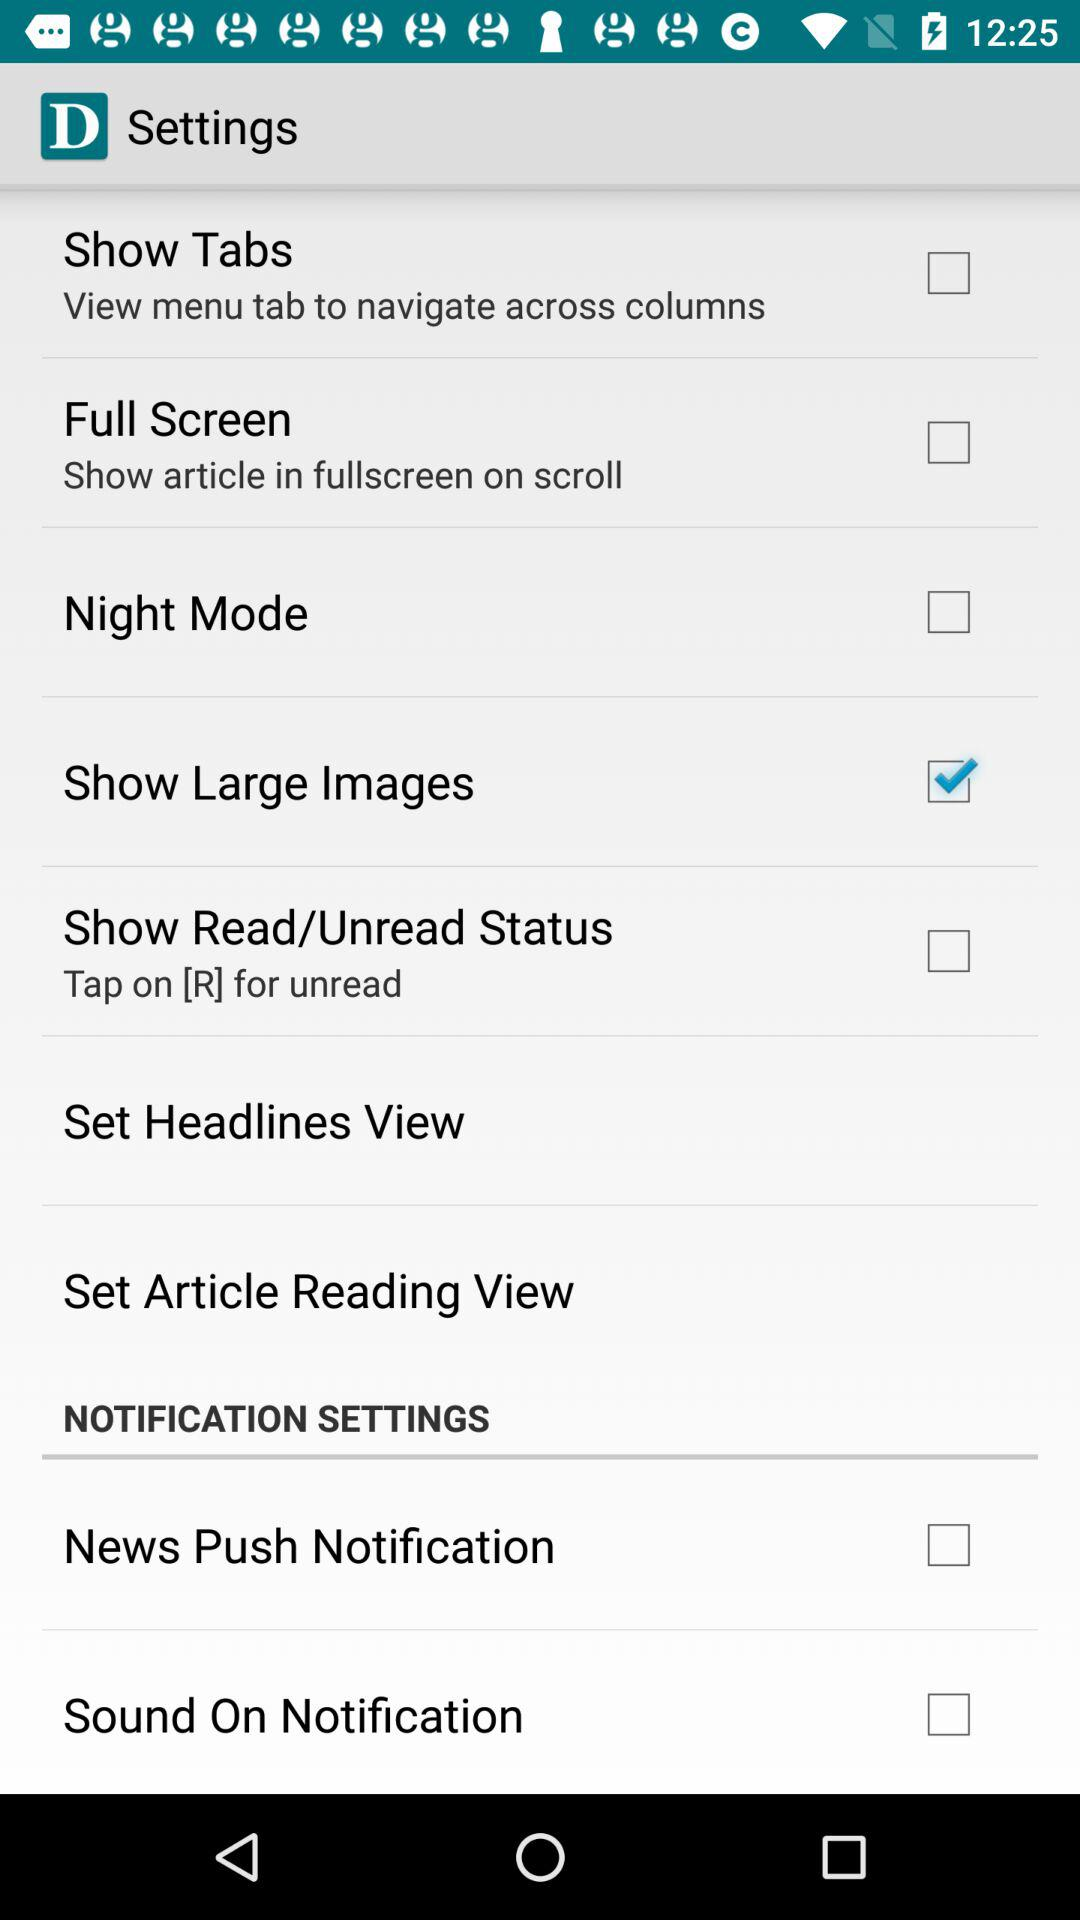Is the article reading view set?
When the provided information is insufficient, respond with <no answer>. <no answer> 